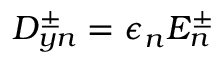Convert formula to latex. <formula><loc_0><loc_0><loc_500><loc_500>D _ { y n } ^ { \pm } = \epsilon _ { n } E _ { n } ^ { \pm }</formula> 